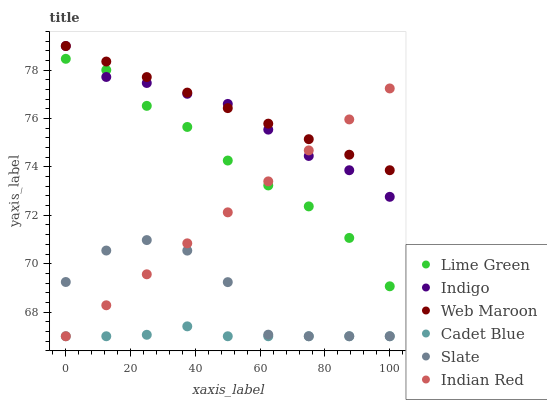Does Cadet Blue have the minimum area under the curve?
Answer yes or no. Yes. Does Web Maroon have the maximum area under the curve?
Answer yes or no. Yes. Does Indigo have the minimum area under the curve?
Answer yes or no. No. Does Indigo have the maximum area under the curve?
Answer yes or no. No. Is Indian Red the smoothest?
Answer yes or no. Yes. Is Slate the roughest?
Answer yes or no. Yes. Is Indigo the smoothest?
Answer yes or no. No. Is Indigo the roughest?
Answer yes or no. No. Does Cadet Blue have the lowest value?
Answer yes or no. Yes. Does Indigo have the lowest value?
Answer yes or no. No. Does Web Maroon have the highest value?
Answer yes or no. Yes. Does Slate have the highest value?
Answer yes or no. No. Is Slate less than Lime Green?
Answer yes or no. Yes. Is Indigo greater than Slate?
Answer yes or no. Yes. Does Indigo intersect Web Maroon?
Answer yes or no. Yes. Is Indigo less than Web Maroon?
Answer yes or no. No. Is Indigo greater than Web Maroon?
Answer yes or no. No. Does Slate intersect Lime Green?
Answer yes or no. No. 